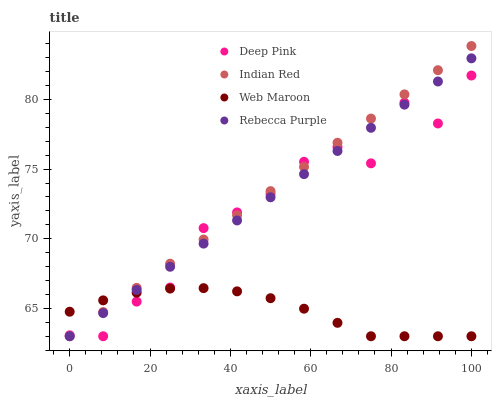Does Web Maroon have the minimum area under the curve?
Answer yes or no. Yes. Does Indian Red have the maximum area under the curve?
Answer yes or no. Yes. Does Rebecca Purple have the minimum area under the curve?
Answer yes or no. No. Does Rebecca Purple have the maximum area under the curve?
Answer yes or no. No. Is Rebecca Purple the smoothest?
Answer yes or no. Yes. Is Deep Pink the roughest?
Answer yes or no. Yes. Is Web Maroon the smoothest?
Answer yes or no. No. Is Web Maroon the roughest?
Answer yes or no. No. Does Deep Pink have the lowest value?
Answer yes or no. Yes. Does Indian Red have the highest value?
Answer yes or no. Yes. Does Rebecca Purple have the highest value?
Answer yes or no. No. Does Deep Pink intersect Indian Red?
Answer yes or no. Yes. Is Deep Pink less than Indian Red?
Answer yes or no. No. Is Deep Pink greater than Indian Red?
Answer yes or no. No. 